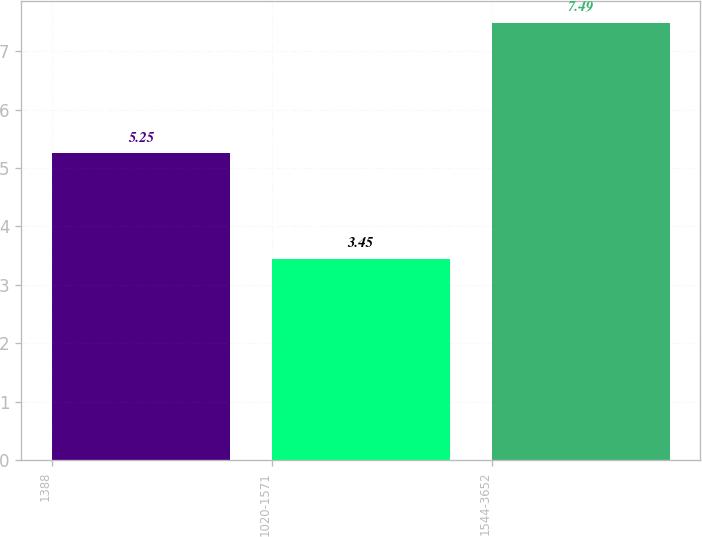Convert chart to OTSL. <chart><loc_0><loc_0><loc_500><loc_500><bar_chart><fcel>1388<fcel>1020-1571<fcel>1544-3652<nl><fcel>5.25<fcel>3.45<fcel>7.49<nl></chart> 